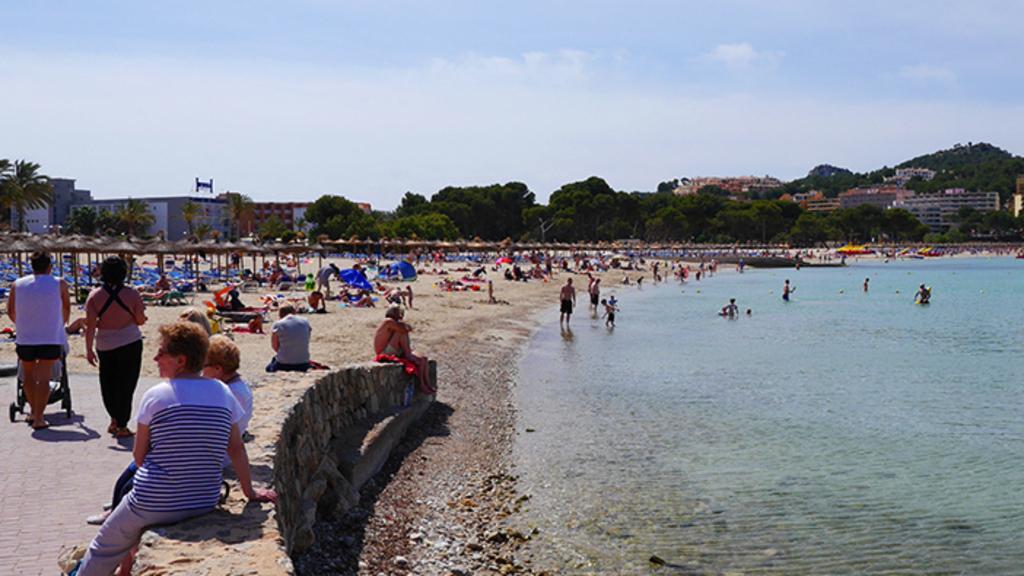Can you describe this image briefly? In this image, we can see some people in the water, there are some people sitting and we can see two people walking, we can see some homes and there are some green trees, at the top there is a sky. 